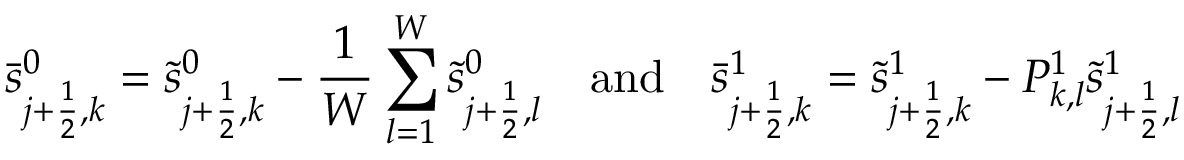<formula> <loc_0><loc_0><loc_500><loc_500>\bar { s } _ { j + \frac { 1 } { 2 } , k } ^ { 0 } = \tilde { s } _ { j + \frac { 1 } { 2 } , k } ^ { 0 } - \frac { 1 } { W } \sum _ { l = 1 } ^ { W } \tilde { s } _ { j + \frac { 1 } { 2 } , l } ^ { 0 } \quad a n d \quad \bar { s } _ { j + \frac { 1 } { 2 } , k } ^ { 1 } = \tilde { s } _ { j + \frac { 1 } { 2 } , k } ^ { 1 } - P _ { k , l } ^ { 1 } \tilde { s } _ { j + \frac { 1 } { 2 } , l } ^ { 1 }</formula> 